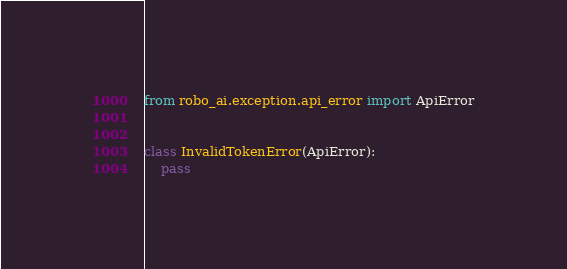<code> <loc_0><loc_0><loc_500><loc_500><_Python_>from robo_ai.exception.api_error import ApiError


class InvalidTokenError(ApiError):
    pass
</code> 